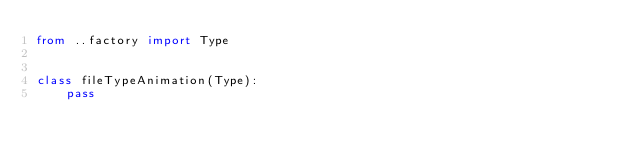<code> <loc_0><loc_0><loc_500><loc_500><_Python_>from ..factory import Type


class fileTypeAnimation(Type):
	pass
</code> 